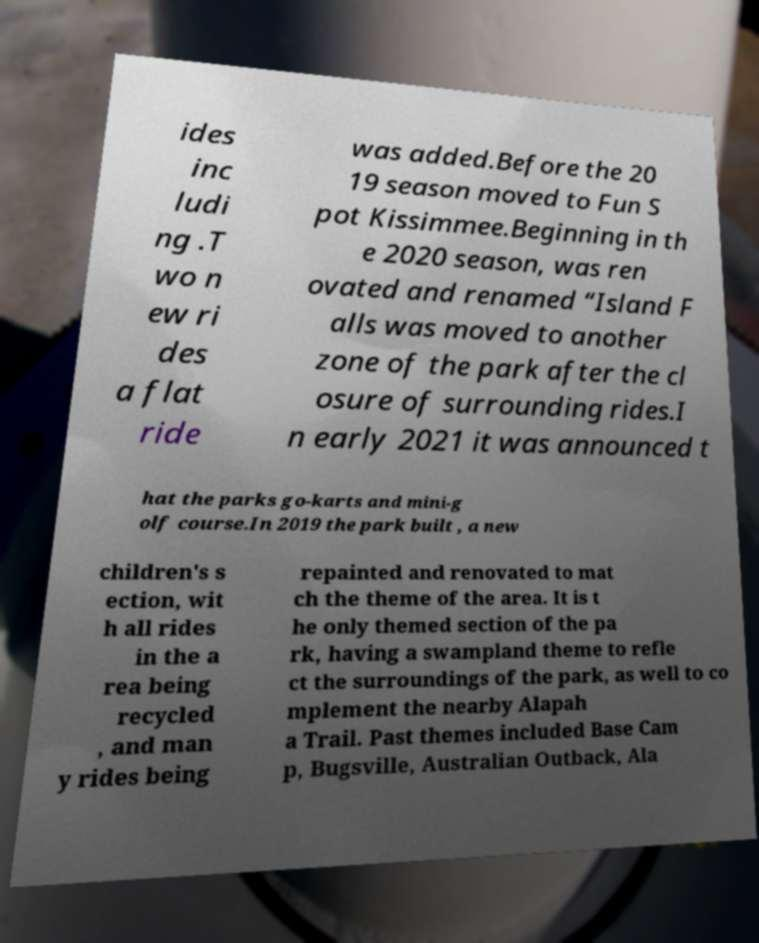Can you read and provide the text displayed in the image?This photo seems to have some interesting text. Can you extract and type it out for me? ides inc ludi ng .T wo n ew ri des a flat ride was added.Before the 20 19 season moved to Fun S pot Kissimmee.Beginning in th e 2020 season, was ren ovated and renamed “Island F alls was moved to another zone of the park after the cl osure of surrounding rides.I n early 2021 it was announced t hat the parks go-karts and mini-g olf course.In 2019 the park built , a new children's s ection, wit h all rides in the a rea being recycled , and man y rides being repainted and renovated to mat ch the theme of the area. It is t he only themed section of the pa rk, having a swampland theme to refle ct the surroundings of the park, as well to co mplement the nearby Alapah a Trail. Past themes included Base Cam p, Bugsville, Australian Outback, Ala 